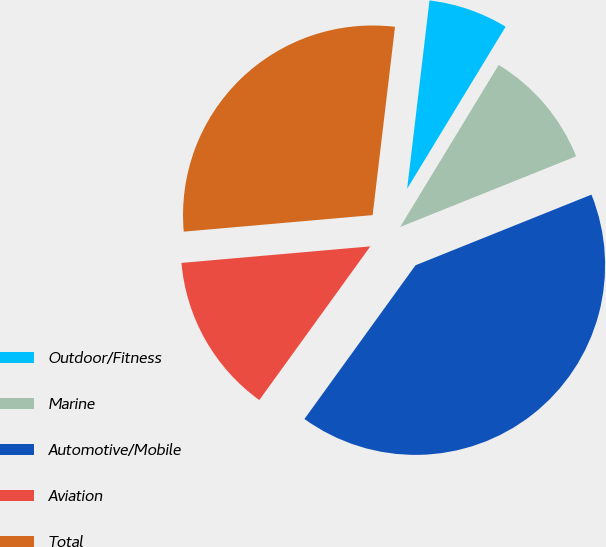Convert chart. <chart><loc_0><loc_0><loc_500><loc_500><pie_chart><fcel>Outdoor/Fitness<fcel>Marine<fcel>Automotive/Mobile<fcel>Aviation<fcel>Total<nl><fcel>6.81%<fcel>10.23%<fcel>41.03%<fcel>13.65%<fcel>28.27%<nl></chart> 